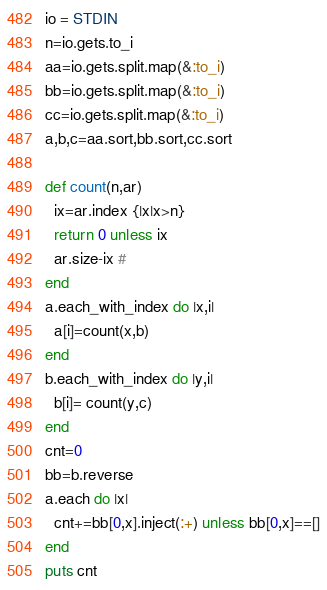<code> <loc_0><loc_0><loc_500><loc_500><_Ruby_>io = STDIN
n=io.gets.to_i
aa=io.gets.split.map(&:to_i)
bb=io.gets.split.map(&:to_i)
cc=io.gets.split.map(&:to_i)
a,b,c=aa.sort,bb.sort,cc.sort

def count(n,ar)
  ix=ar.index {|x|x>n}
  return 0 unless ix
  ar.size-ix #
end
a.each_with_index do |x,i|
  a[i]=count(x,b)
end
b.each_with_index do |y,i|
  b[i]= count(y,c)
end
cnt=0
bb=b.reverse
a.each do |x|
  cnt+=bb[0,x].inject(:+) unless bb[0,x]==[]
end
puts cnt
</code> 